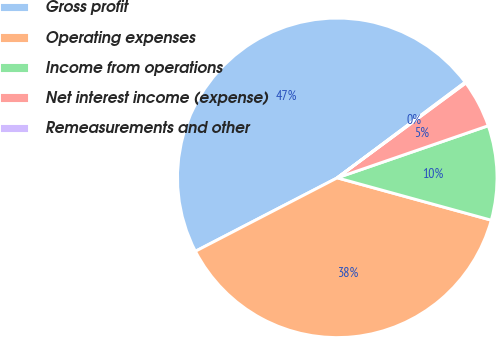Convert chart to OTSL. <chart><loc_0><loc_0><loc_500><loc_500><pie_chart><fcel>Gross profit<fcel>Operating expenses<fcel>Income from operations<fcel>Net interest income (expense)<fcel>Remeasurements and other<nl><fcel>47.39%<fcel>38.13%<fcel>9.56%<fcel>4.83%<fcel>0.1%<nl></chart> 